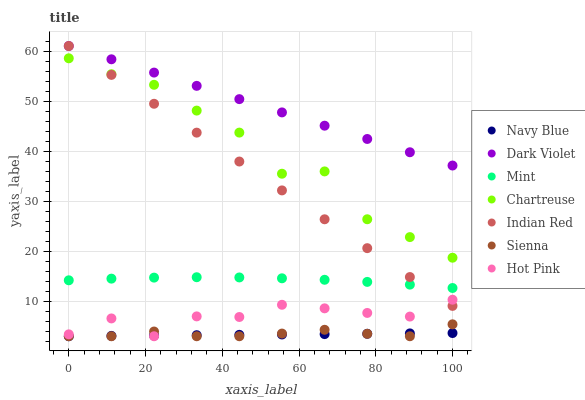Does Navy Blue have the minimum area under the curve?
Answer yes or no. Yes. Does Dark Violet have the maximum area under the curve?
Answer yes or no. Yes. Does Hot Pink have the minimum area under the curve?
Answer yes or no. No. Does Hot Pink have the maximum area under the curve?
Answer yes or no. No. Is Navy Blue the smoothest?
Answer yes or no. Yes. Is Chartreuse the roughest?
Answer yes or no. Yes. Is Hot Pink the smoothest?
Answer yes or no. No. Is Hot Pink the roughest?
Answer yes or no. No. Does Navy Blue have the lowest value?
Answer yes or no. Yes. Does Dark Violet have the lowest value?
Answer yes or no. No. Does Indian Red have the highest value?
Answer yes or no. Yes. Does Hot Pink have the highest value?
Answer yes or no. No. Is Navy Blue less than Chartreuse?
Answer yes or no. Yes. Is Chartreuse greater than Mint?
Answer yes or no. Yes. Does Mint intersect Indian Red?
Answer yes or no. Yes. Is Mint less than Indian Red?
Answer yes or no. No. Is Mint greater than Indian Red?
Answer yes or no. No. Does Navy Blue intersect Chartreuse?
Answer yes or no. No. 